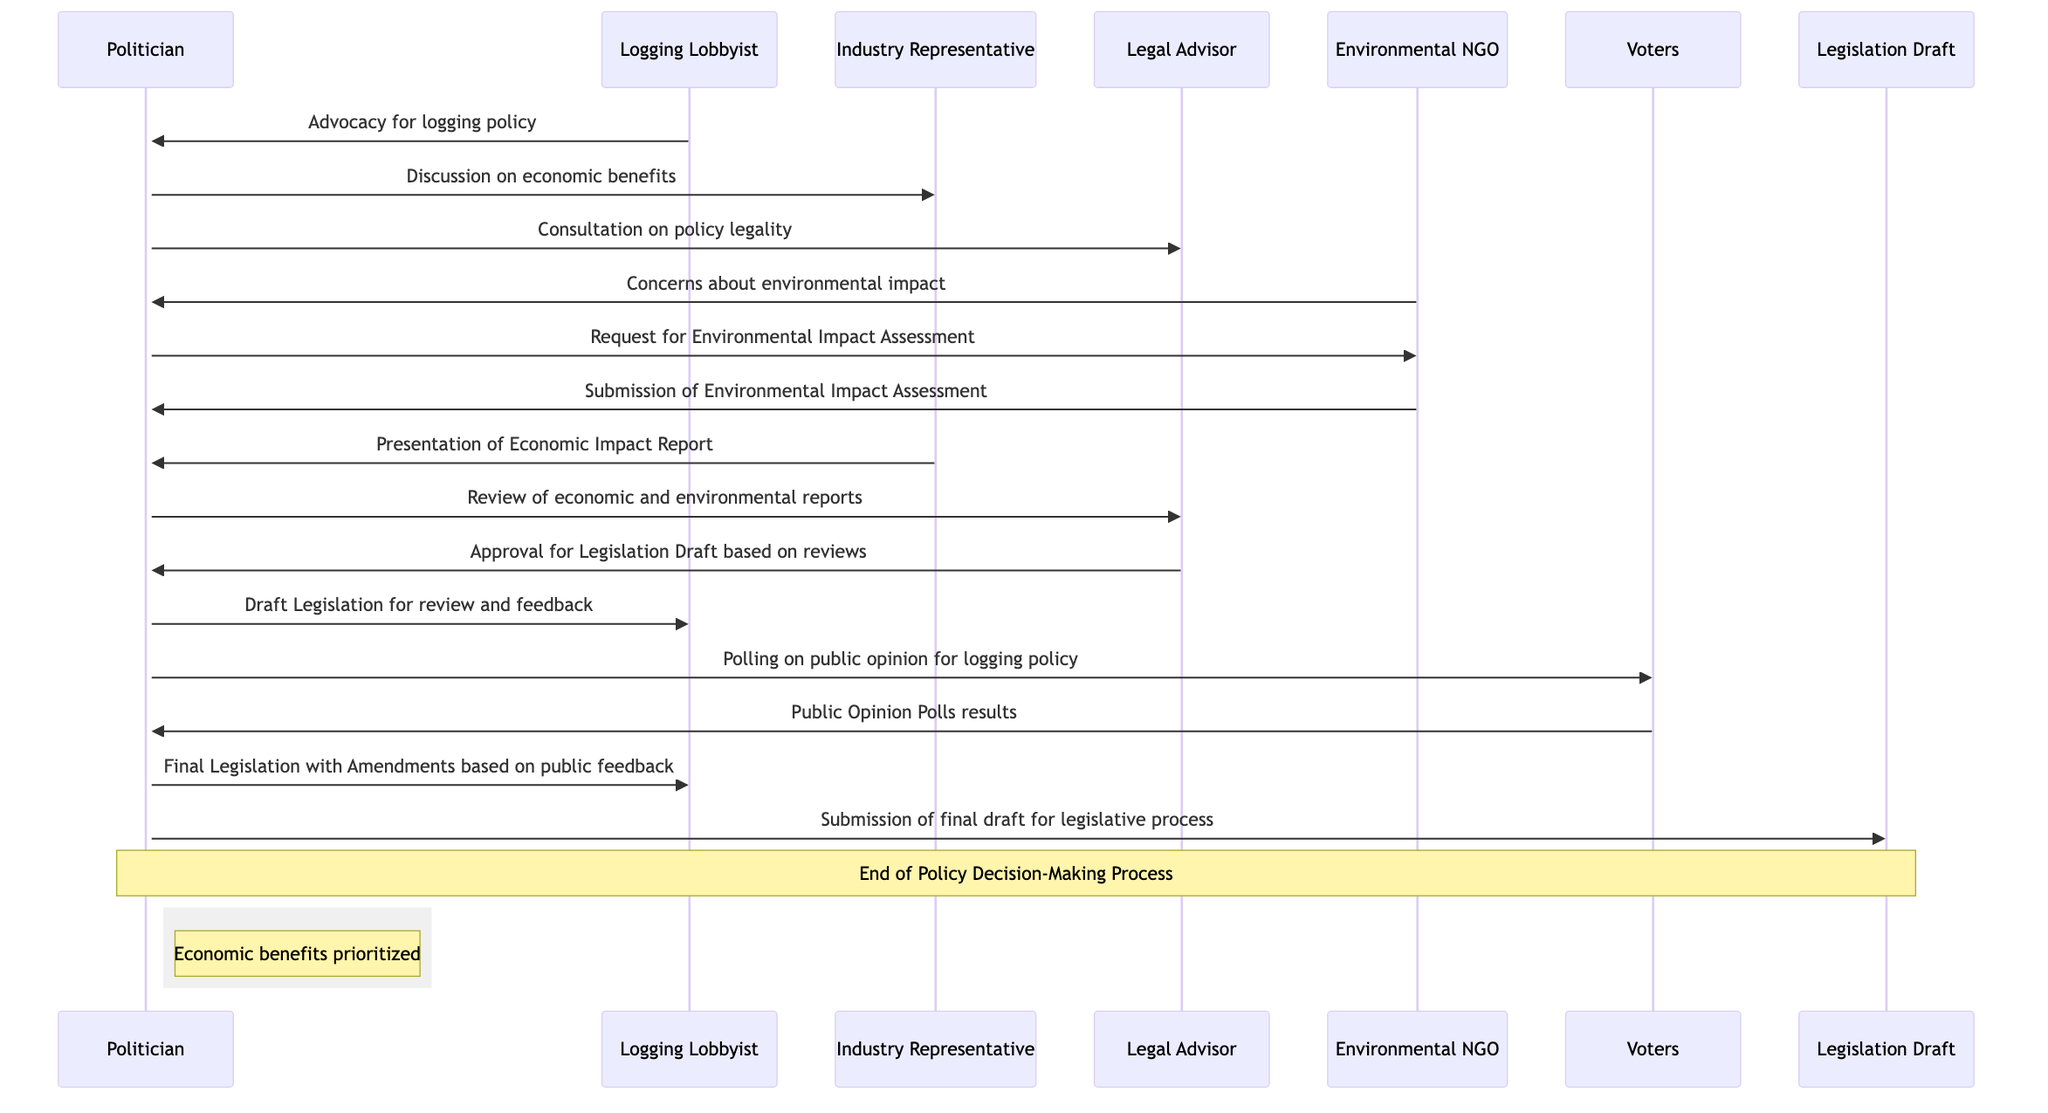What is the first message exchanged in the diagram? The first message is sent from the Logging Lobbyist to the Politician, which is an advocacy for logging policy.
Answer: Advocacy for logging policy How many actors are involved in the decision-making process? There are six actors involved: Politician, Logging Lobbyist, Environmental NGO, Industry Representative, Legal Advisor, and Voters.
Answer: Six Who requests the Environmental Impact Assessment? The Politician requests the Environmental Impact Assessment from the Environmental NGO.
Answer: Politician What type of report is presented by the Industry Representative? The type of report presented is the Economic Impact Report.
Answer: Economic Impact Report What is the final output after gathering public opinion? The final output is the Final Legislation with Amendments based on public feedback.
Answer: Final Legislation with Amendments How many messages does the Politician send in total? The Politician sends a total of six messages throughout the process.
Answer: Six What step follows the submission of the Environmental Impact Assessment? The step that follows is the presentation of the Economic Impact Report by the Industry Representative.
Answer: Presentation of Economic Impact Report Which entity does the Legal Advisor provide feedback to in the process? The Legal Advisor provides feedback to the Politician regarding the legislation draft based on the reviews.
Answer: Politician What note is indicated at the end of the process? The note indicated is that the end of the Policy Decision-Making Process has occurred.
Answer: End of Policy Decision-Making Process 